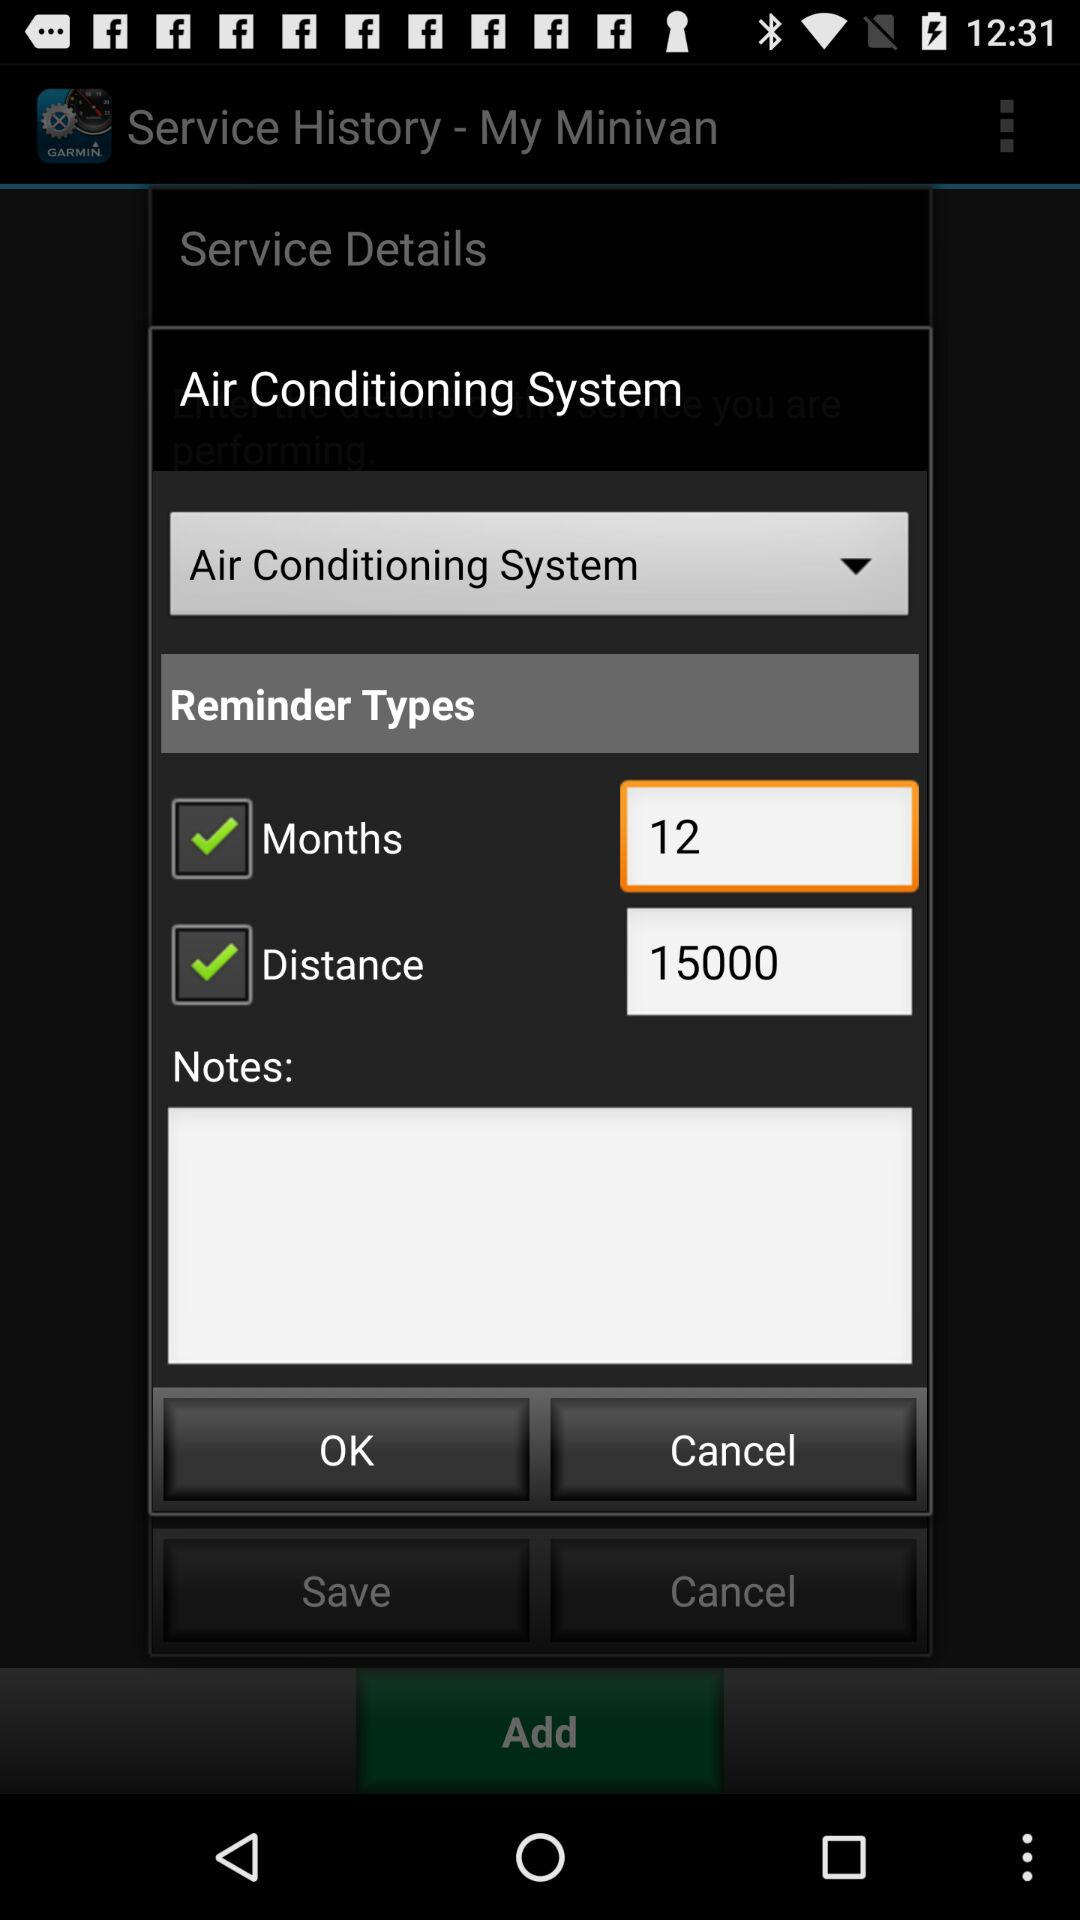How many reminder types are available?
Answer the question using a single word or phrase. 2 